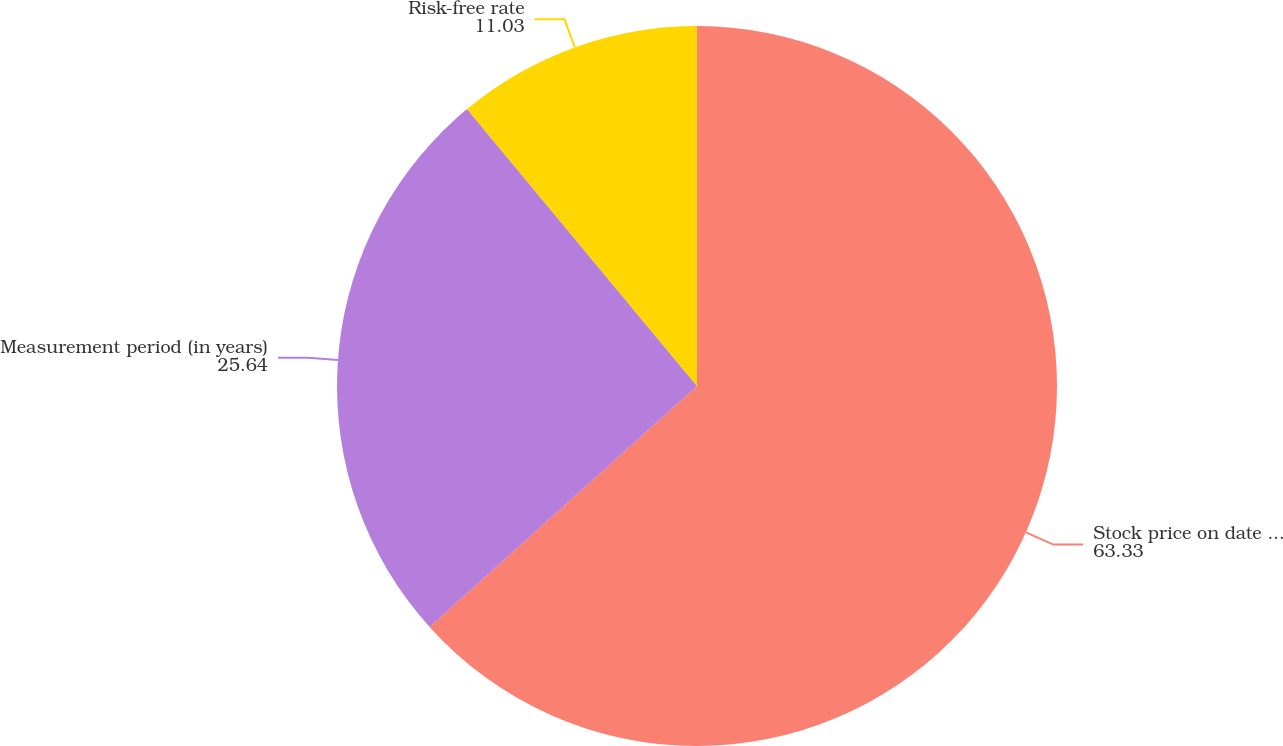Convert chart. <chart><loc_0><loc_0><loc_500><loc_500><pie_chart><fcel>Stock price on date of grant<fcel>Measurement period (in years)<fcel>Risk-free rate<nl><fcel>63.33%<fcel>25.64%<fcel>11.03%<nl></chart> 